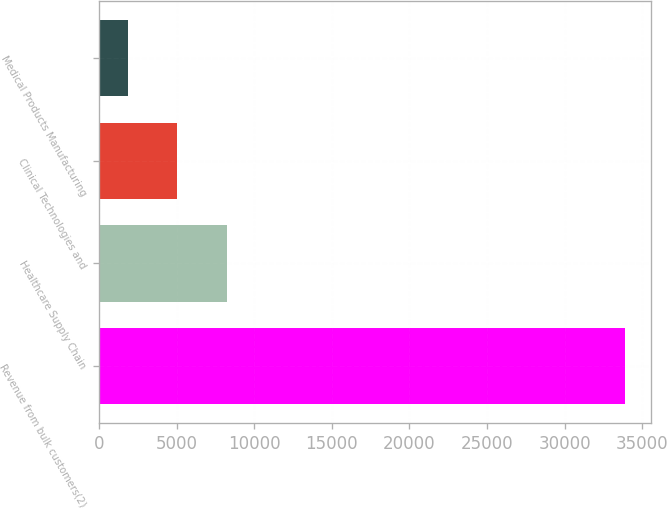Convert chart to OTSL. <chart><loc_0><loc_0><loc_500><loc_500><bar_chart><fcel>Revenue from bulk customers(2)<fcel>Healthcare Supply Chain<fcel>Clinical Technologies and<fcel>Medical Products Manufacturing<nl><fcel>33900<fcel>8248.72<fcel>5042.31<fcel>1835.9<nl></chart> 